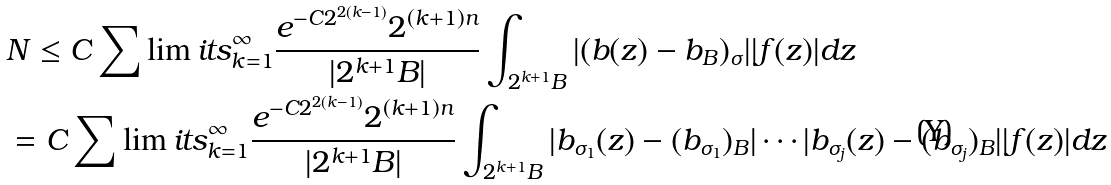<formula> <loc_0><loc_0><loc_500><loc_500>& N \leq C \sum \lim i t s _ { k = 1 } ^ { \infty } \frac { e ^ { - C 2 ^ { 2 ( k - 1 ) } } 2 ^ { ( k + 1 ) n } } { | 2 ^ { k + 1 } B | } \int _ { 2 ^ { k + 1 } B } | ( b ( z ) - b _ { B } ) _ { \sigma } | | f ( z ) | d z \\ & = C \sum \lim i t s _ { k = 1 } ^ { \infty } \frac { e ^ { - C 2 ^ { 2 ( k - 1 ) } } 2 ^ { ( k + 1 ) n } } { | 2 ^ { k + 1 } B | } \int _ { 2 ^ { k + 1 } B } | b _ { \sigma _ { 1 } } ( z ) - ( b _ { \sigma _ { 1 } } ) _ { B } | \cdots | b _ { \sigma _ { j } } ( z ) - ( b _ { \sigma _ { j } } ) _ { B } | | f ( z ) | d z</formula> 